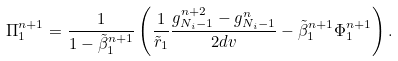<formula> <loc_0><loc_0><loc_500><loc_500>\Pi ^ { n + 1 } _ { 1 } = \frac { 1 } { 1 - \tilde { \beta } ^ { n + 1 } _ { 1 } } \left ( \frac { 1 } { \tilde { r } _ { 1 } } \frac { g ^ { n + 2 } _ { N _ { i } - 1 } - g ^ { n } _ { N _ { i } - 1 } } { 2 d v } - \tilde { \beta } ^ { n + 1 } _ { 1 } \Phi ^ { n + 1 } _ { 1 } \right ) .</formula> 